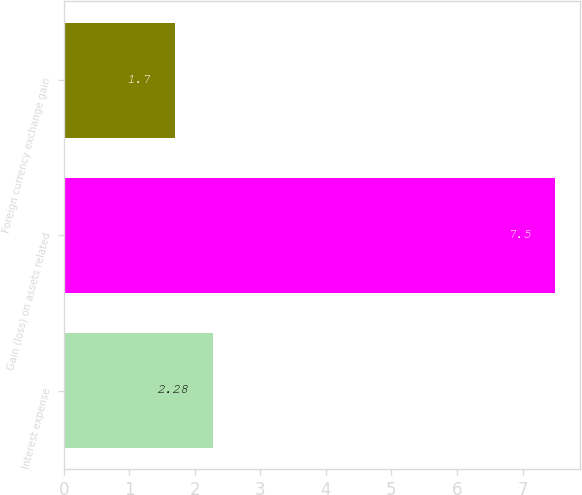Convert chart to OTSL. <chart><loc_0><loc_0><loc_500><loc_500><bar_chart><fcel>Interest expense<fcel>Gain (loss) on assets related<fcel>Foreign currency exchange gain<nl><fcel>2.28<fcel>7.5<fcel>1.7<nl></chart> 